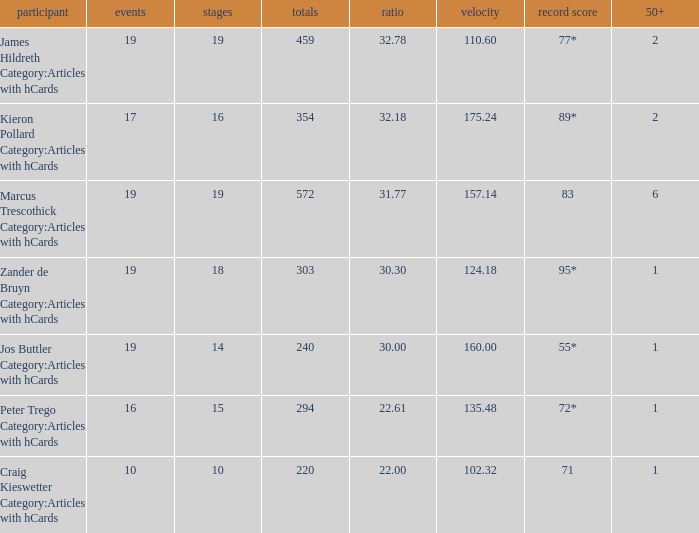How many innings for the player with an average of 22.61? 15.0. 